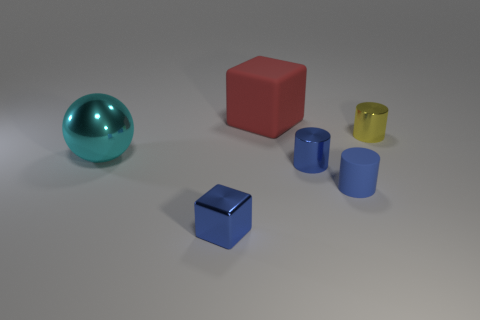Subtract all small yellow cylinders. How many cylinders are left? 2 Add 1 blue things. How many objects exist? 7 Subtract 1 balls. How many balls are left? 0 Subtract all blue cubes. How many cubes are left? 1 Subtract all blocks. How many objects are left? 4 Subtract all tiny matte things. Subtract all big spheres. How many objects are left? 4 Add 4 small blue cylinders. How many small blue cylinders are left? 6 Add 3 red rubber things. How many red rubber things exist? 4 Subtract 0 green cylinders. How many objects are left? 6 Subtract all cyan cubes. Subtract all purple cylinders. How many cubes are left? 2 